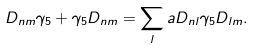<formula> <loc_0><loc_0><loc_500><loc_500>D _ { n m } \gamma _ { 5 } + \gamma _ { 5 } D _ { n m } = \sum _ { l } a D _ { n l } \gamma _ { 5 } D _ { l m } .</formula> 